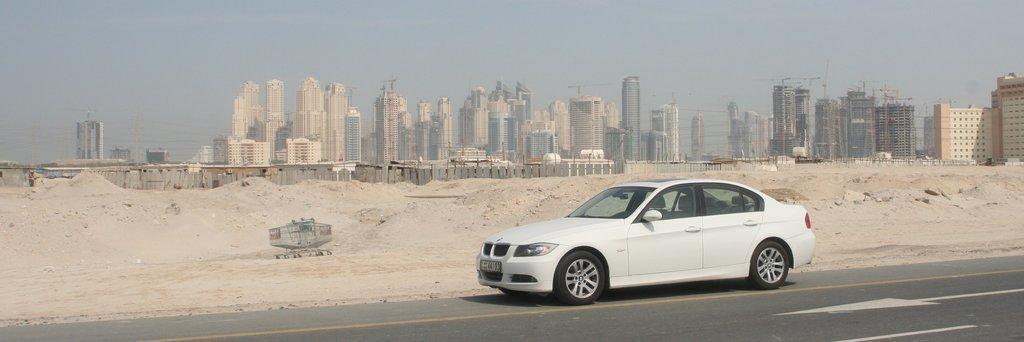In one or two sentences, can you explain what this image depicts? In the foreground we can see the road. Here we can see a car on the road. In the background, we can see the tower buildings. Here we can see the sand. Here we can see the fence. 